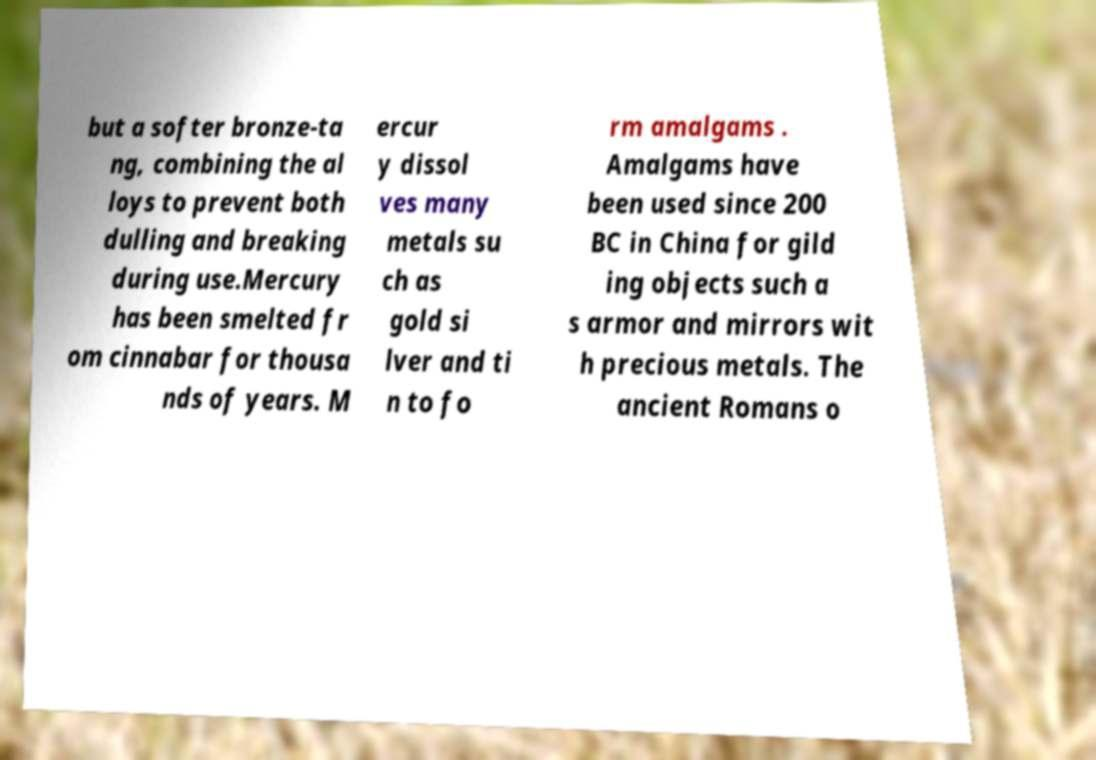Please read and relay the text visible in this image. What does it say? but a softer bronze-ta ng, combining the al loys to prevent both dulling and breaking during use.Mercury has been smelted fr om cinnabar for thousa nds of years. M ercur y dissol ves many metals su ch as gold si lver and ti n to fo rm amalgams . Amalgams have been used since 200 BC in China for gild ing objects such a s armor and mirrors wit h precious metals. The ancient Romans o 